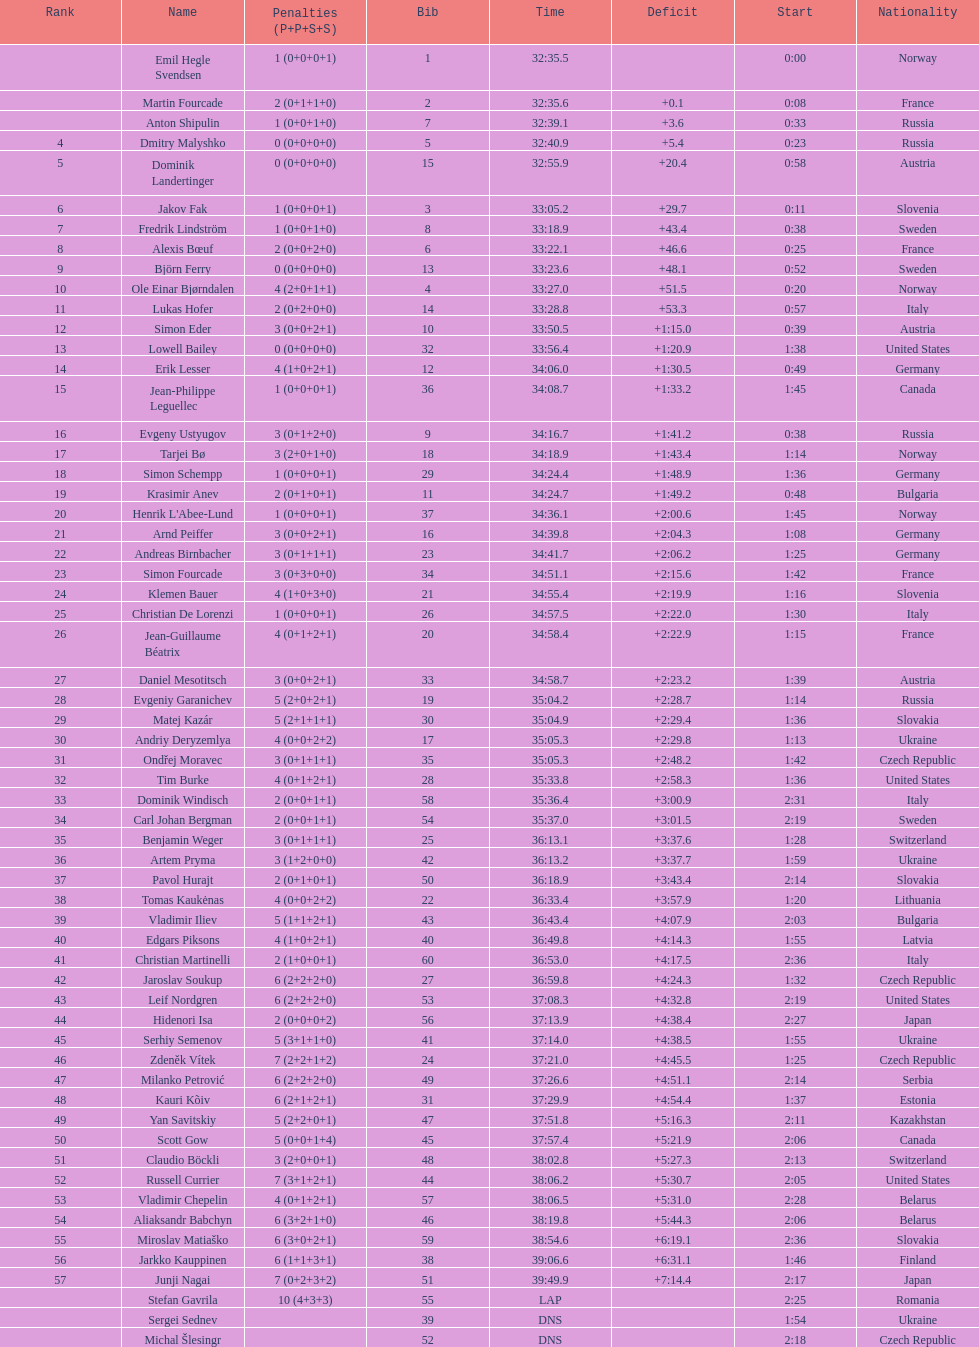Would you be able to parse every entry in this table? {'header': ['Rank', 'Name', 'Penalties (P+P+S+S)', 'Bib', 'Time', 'Deficit', 'Start', 'Nationality'], 'rows': [['', 'Emil Hegle Svendsen', '1 (0+0+0+1)', '1', '32:35.5', '', '0:00', 'Norway'], ['', 'Martin Fourcade', '2 (0+1+1+0)', '2', '32:35.6', '+0.1', '0:08', 'France'], ['', 'Anton Shipulin', '1 (0+0+1+0)', '7', '32:39.1', '+3.6', '0:33', 'Russia'], ['4', 'Dmitry Malyshko', '0 (0+0+0+0)', '5', '32:40.9', '+5.4', '0:23', 'Russia'], ['5', 'Dominik Landertinger', '0 (0+0+0+0)', '15', '32:55.9', '+20.4', '0:58', 'Austria'], ['6', 'Jakov Fak', '1 (0+0+0+1)', '3', '33:05.2', '+29.7', '0:11', 'Slovenia'], ['7', 'Fredrik Lindström', '1 (0+0+1+0)', '8', '33:18.9', '+43.4', '0:38', 'Sweden'], ['8', 'Alexis Bœuf', '2 (0+0+2+0)', '6', '33:22.1', '+46.6', '0:25', 'France'], ['9', 'Björn Ferry', '0 (0+0+0+0)', '13', '33:23.6', '+48.1', '0:52', 'Sweden'], ['10', 'Ole Einar Bjørndalen', '4 (2+0+1+1)', '4', '33:27.0', '+51.5', '0:20', 'Norway'], ['11', 'Lukas Hofer', '2 (0+2+0+0)', '14', '33:28.8', '+53.3', '0:57', 'Italy'], ['12', 'Simon Eder', '3 (0+0+2+1)', '10', '33:50.5', '+1:15.0', '0:39', 'Austria'], ['13', 'Lowell Bailey', '0 (0+0+0+0)', '32', '33:56.4', '+1:20.9', '1:38', 'United States'], ['14', 'Erik Lesser', '4 (1+0+2+1)', '12', '34:06.0', '+1:30.5', '0:49', 'Germany'], ['15', 'Jean-Philippe Leguellec', '1 (0+0+0+1)', '36', '34:08.7', '+1:33.2', '1:45', 'Canada'], ['16', 'Evgeny Ustyugov', '3 (0+1+2+0)', '9', '34:16.7', '+1:41.2', '0:38', 'Russia'], ['17', 'Tarjei Bø', '3 (2+0+1+0)', '18', '34:18.9', '+1:43.4', '1:14', 'Norway'], ['18', 'Simon Schempp', '1 (0+0+0+1)', '29', '34:24.4', '+1:48.9', '1:36', 'Germany'], ['19', 'Krasimir Anev', '2 (0+1+0+1)', '11', '34:24.7', '+1:49.2', '0:48', 'Bulgaria'], ['20', "Henrik L'Abee-Lund", '1 (0+0+0+1)', '37', '34:36.1', '+2:00.6', '1:45', 'Norway'], ['21', 'Arnd Peiffer', '3 (0+0+2+1)', '16', '34:39.8', '+2:04.3', '1:08', 'Germany'], ['22', 'Andreas Birnbacher', '3 (0+1+1+1)', '23', '34:41.7', '+2:06.2', '1:25', 'Germany'], ['23', 'Simon Fourcade', '3 (0+3+0+0)', '34', '34:51.1', '+2:15.6', '1:42', 'France'], ['24', 'Klemen Bauer', '4 (1+0+3+0)', '21', '34:55.4', '+2:19.9', '1:16', 'Slovenia'], ['25', 'Christian De Lorenzi', '1 (0+0+0+1)', '26', '34:57.5', '+2:22.0', '1:30', 'Italy'], ['26', 'Jean-Guillaume Béatrix', '4 (0+1+2+1)', '20', '34:58.4', '+2:22.9', '1:15', 'France'], ['27', 'Daniel Mesotitsch', '3 (0+0+2+1)', '33', '34:58.7', '+2:23.2', '1:39', 'Austria'], ['28', 'Evgeniy Garanichev', '5 (2+0+2+1)', '19', '35:04.2', '+2:28.7', '1:14', 'Russia'], ['29', 'Matej Kazár', '5 (2+1+1+1)', '30', '35:04.9', '+2:29.4', '1:36', 'Slovakia'], ['30', 'Andriy Deryzemlya', '4 (0+0+2+2)', '17', '35:05.3', '+2:29.8', '1:13', 'Ukraine'], ['31', 'Ondřej Moravec', '3 (0+1+1+1)', '35', '35:05.3', '+2:48.2', '1:42', 'Czech Republic'], ['32', 'Tim Burke', '4 (0+1+2+1)', '28', '35:33.8', '+2:58.3', '1:36', 'United States'], ['33', 'Dominik Windisch', '2 (0+0+1+1)', '58', '35:36.4', '+3:00.9', '2:31', 'Italy'], ['34', 'Carl Johan Bergman', '2 (0+0+1+1)', '54', '35:37.0', '+3:01.5', '2:19', 'Sweden'], ['35', 'Benjamin Weger', '3 (0+1+1+1)', '25', '36:13.1', '+3:37.6', '1:28', 'Switzerland'], ['36', 'Artem Pryma', '3 (1+2+0+0)', '42', '36:13.2', '+3:37.7', '1:59', 'Ukraine'], ['37', 'Pavol Hurajt', '2 (0+1+0+1)', '50', '36:18.9', '+3:43.4', '2:14', 'Slovakia'], ['38', 'Tomas Kaukėnas', '4 (0+0+2+2)', '22', '36:33.4', '+3:57.9', '1:20', 'Lithuania'], ['39', 'Vladimir Iliev', '5 (1+1+2+1)', '43', '36:43.4', '+4:07.9', '2:03', 'Bulgaria'], ['40', 'Edgars Piksons', '4 (1+0+2+1)', '40', '36:49.8', '+4:14.3', '1:55', 'Latvia'], ['41', 'Christian Martinelli', '2 (1+0+0+1)', '60', '36:53.0', '+4:17.5', '2:36', 'Italy'], ['42', 'Jaroslav Soukup', '6 (2+2+2+0)', '27', '36:59.8', '+4:24.3', '1:32', 'Czech Republic'], ['43', 'Leif Nordgren', '6 (2+2+2+0)', '53', '37:08.3', '+4:32.8', '2:19', 'United States'], ['44', 'Hidenori Isa', '2 (0+0+0+2)', '56', '37:13.9', '+4:38.4', '2:27', 'Japan'], ['45', 'Serhiy Semenov', '5 (3+1+1+0)', '41', '37:14.0', '+4:38.5', '1:55', 'Ukraine'], ['46', 'Zdeněk Vítek', '7 (2+2+1+2)', '24', '37:21.0', '+4:45.5', '1:25', 'Czech Republic'], ['47', 'Milanko Petrović', '6 (2+2+2+0)', '49', '37:26.6', '+4:51.1', '2:14', 'Serbia'], ['48', 'Kauri Kõiv', '6 (2+1+2+1)', '31', '37:29.9', '+4:54.4', '1:37', 'Estonia'], ['49', 'Yan Savitskiy', '5 (2+2+0+1)', '47', '37:51.8', '+5:16.3', '2:11', 'Kazakhstan'], ['50', 'Scott Gow', '5 (0+0+1+4)', '45', '37:57.4', '+5:21.9', '2:06', 'Canada'], ['51', 'Claudio Böckli', '3 (2+0+0+1)', '48', '38:02.8', '+5:27.3', '2:13', 'Switzerland'], ['52', 'Russell Currier', '7 (3+1+2+1)', '44', '38:06.2', '+5:30.7', '2:05', 'United States'], ['53', 'Vladimir Chepelin', '4 (0+1+2+1)', '57', '38:06.5', '+5:31.0', '2:28', 'Belarus'], ['54', 'Aliaksandr Babchyn', '6 (3+2+1+0)', '46', '38:19.8', '+5:44.3', '2:06', 'Belarus'], ['55', 'Miroslav Matiaško', '6 (3+0+2+1)', '59', '38:54.6', '+6:19.1', '2:36', 'Slovakia'], ['56', 'Jarkko Kauppinen', '6 (1+1+3+1)', '38', '39:06.6', '+6:31.1', '1:46', 'Finland'], ['57', 'Junji Nagai', '7 (0+2+3+2)', '51', '39:49.9', '+7:14.4', '2:17', 'Japan'], ['', 'Stefan Gavrila', '10 (4+3+3)', '55', 'LAP', '', '2:25', 'Romania'], ['', 'Sergei Sednev', '', '39', 'DNS', '', '1:54', 'Ukraine'], ['', 'Michal Šlesingr', '', '52', 'DNS', '', '2:18', 'Czech Republic']]} How many penalties did germany get all together? 11. 